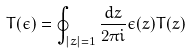<formula> <loc_0><loc_0><loc_500><loc_500>T ( \epsilon ) = \oint _ { | z | = 1 } \frac { d z } { 2 \pi i } \epsilon ( z ) T ( z )</formula> 